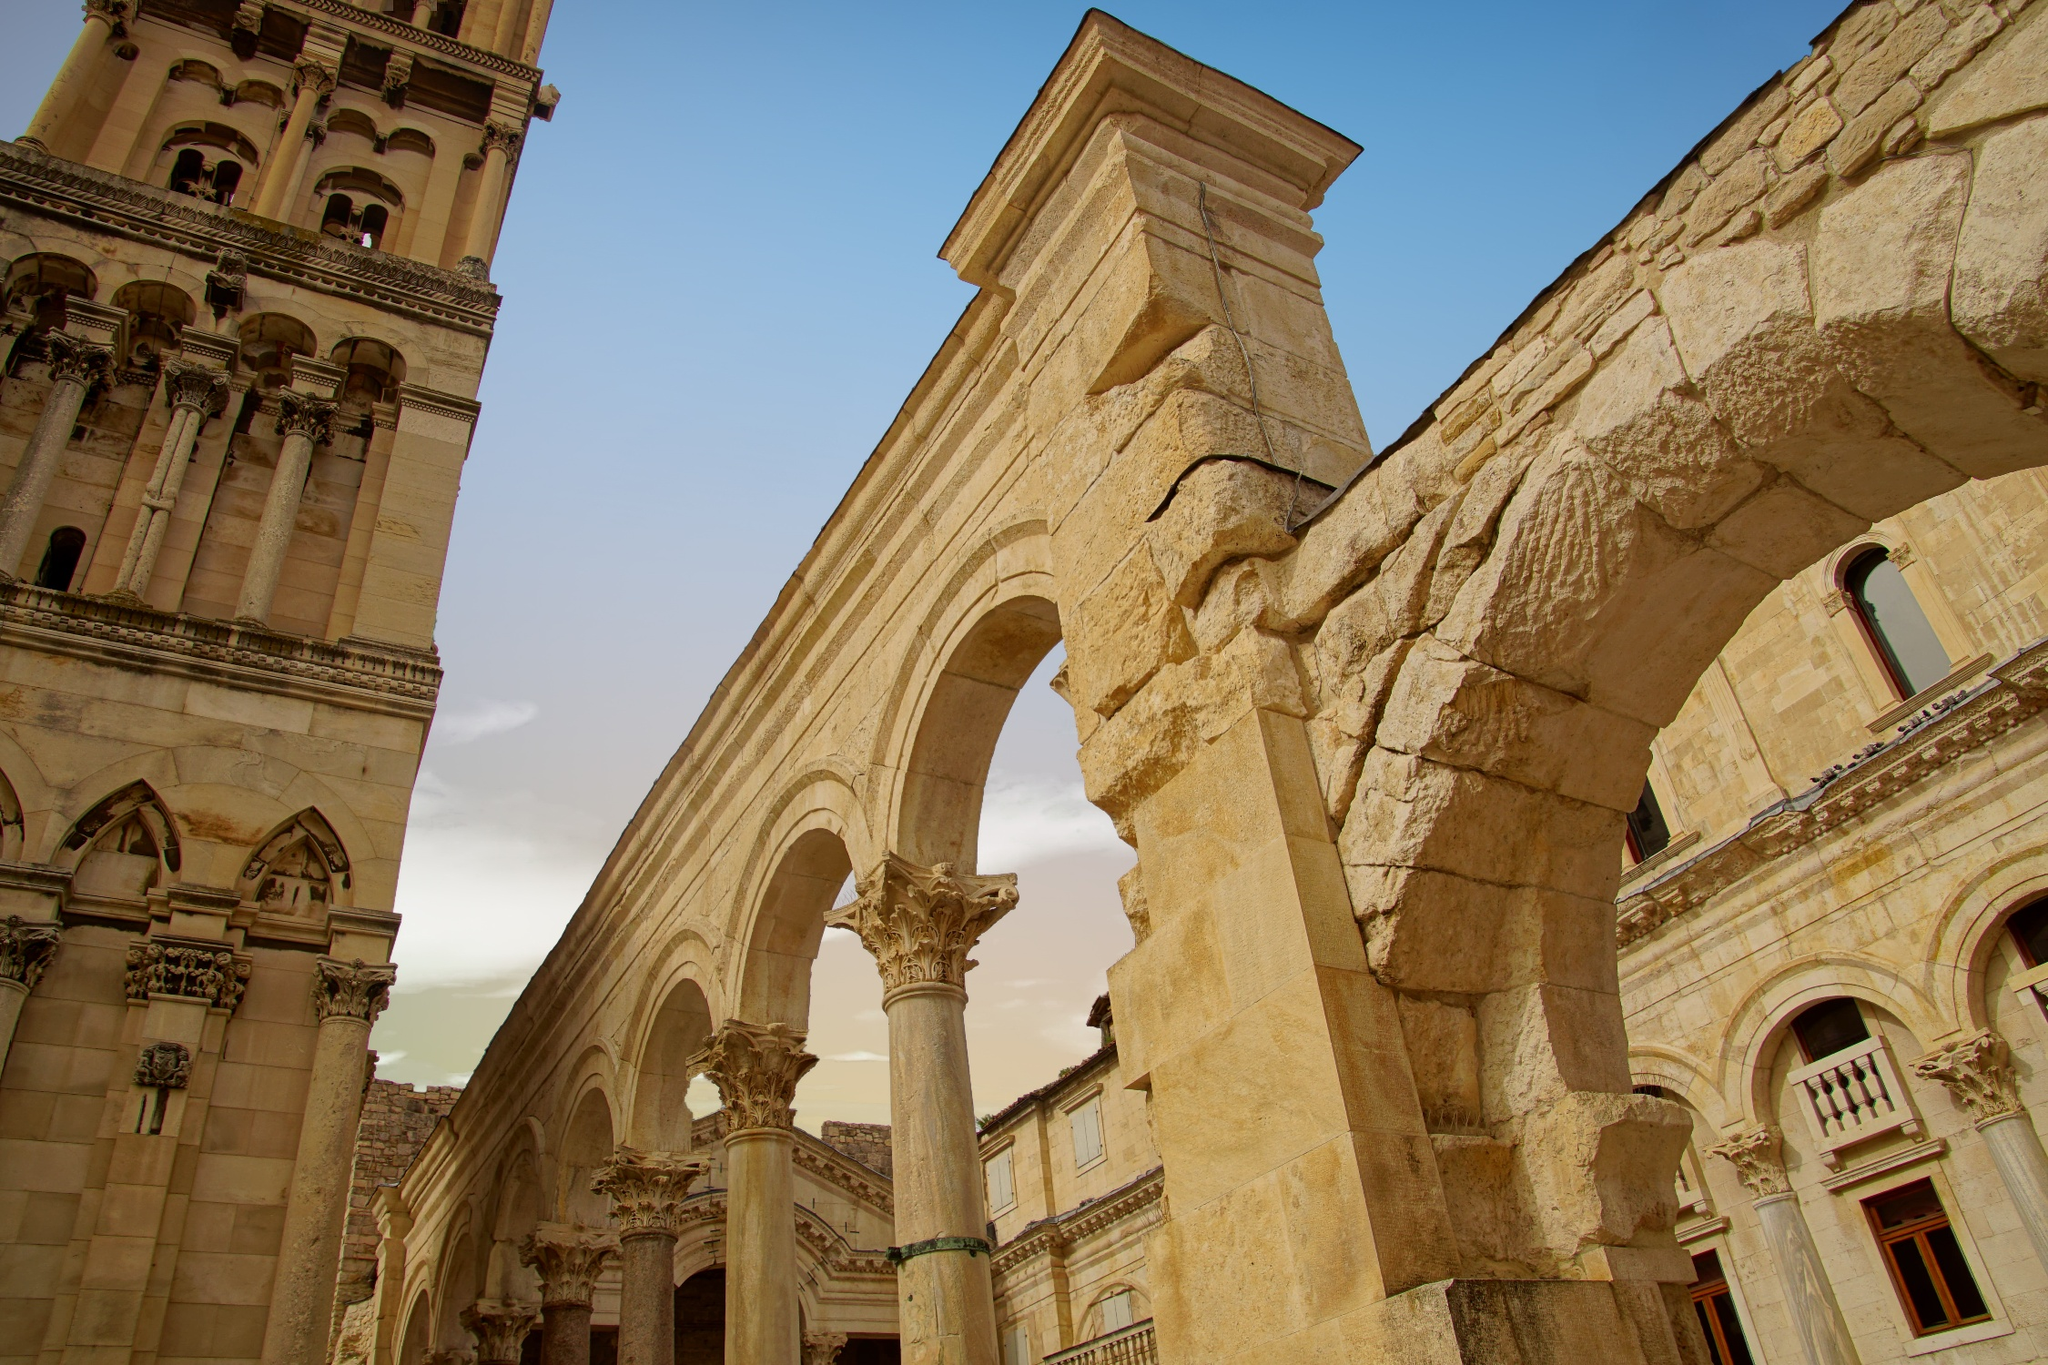How might this site have looked at sunset in ancient times? As the sun began to set over Diocletian’s Palace in ancient times, the light would cast a warm, golden hue over the entire structure. The white stone of the arches and columns would glow softly, creating a serene and almost magical atmosphere. Shadows would lengthen, accentuating the intricate carvings and details of the architecture. The sky would transform into a canvas of deep oranges, pinks, and purples, reflecting off the palace windows and adding to the splendor of the view. People of the time might be seen leisurely strolling through the courtyard, taking in the beauty of the sunset, while perhaps a gentle breeze rustled the banners and garlands that adorned the area. What events or activities would take place here during a typical day in the palace? During a typical day in Diocletian’s Palace, a variety of events and activities would likely have taken place, reflecting the multifaceted life of the Roman Empire. Early in the morning, the palace gates would open to bustling activity. Courtiers and officials would begin their day with meetings and discussions, managing the affairs of the empire. In the courtyard, merchants might set up stalls, selling exotic goods and wares, while artisans showcased their crafts. Citizens could be seen visiting the temple within the palace to offer prayers and sacrifices. The sounds of training soldiers might echo from the courtyard as they practiced drills. By midday, the palace would be alive with the buzz of daily life, from the laughter of children playing to the murmur of servants attending to their duties. As evening approached, the palace would quiet down, with the affluent enjoying lavish dinners and entertainment, while others prepared for the calm of night. 